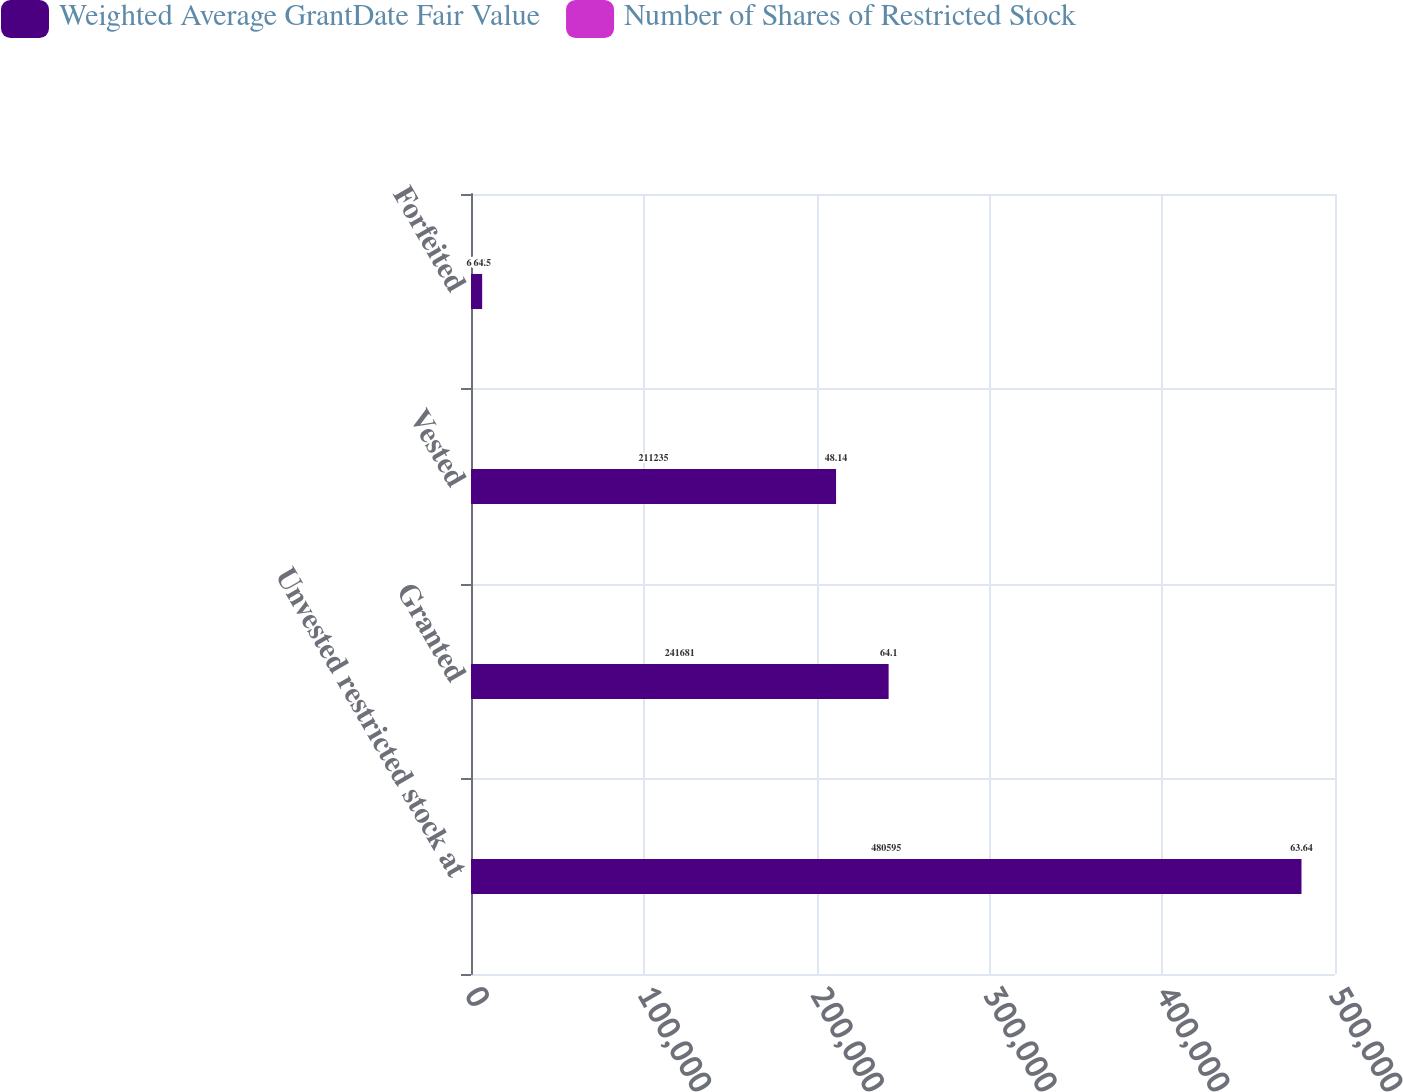Convert chart. <chart><loc_0><loc_0><loc_500><loc_500><stacked_bar_chart><ecel><fcel>Unvested restricted stock at<fcel>Granted<fcel>Vested<fcel>Forfeited<nl><fcel>Weighted Average GrantDate Fair Value<fcel>480595<fcel>241681<fcel>211235<fcel>6421<nl><fcel>Number of Shares of Restricted Stock<fcel>63.64<fcel>64.1<fcel>48.14<fcel>64.5<nl></chart> 